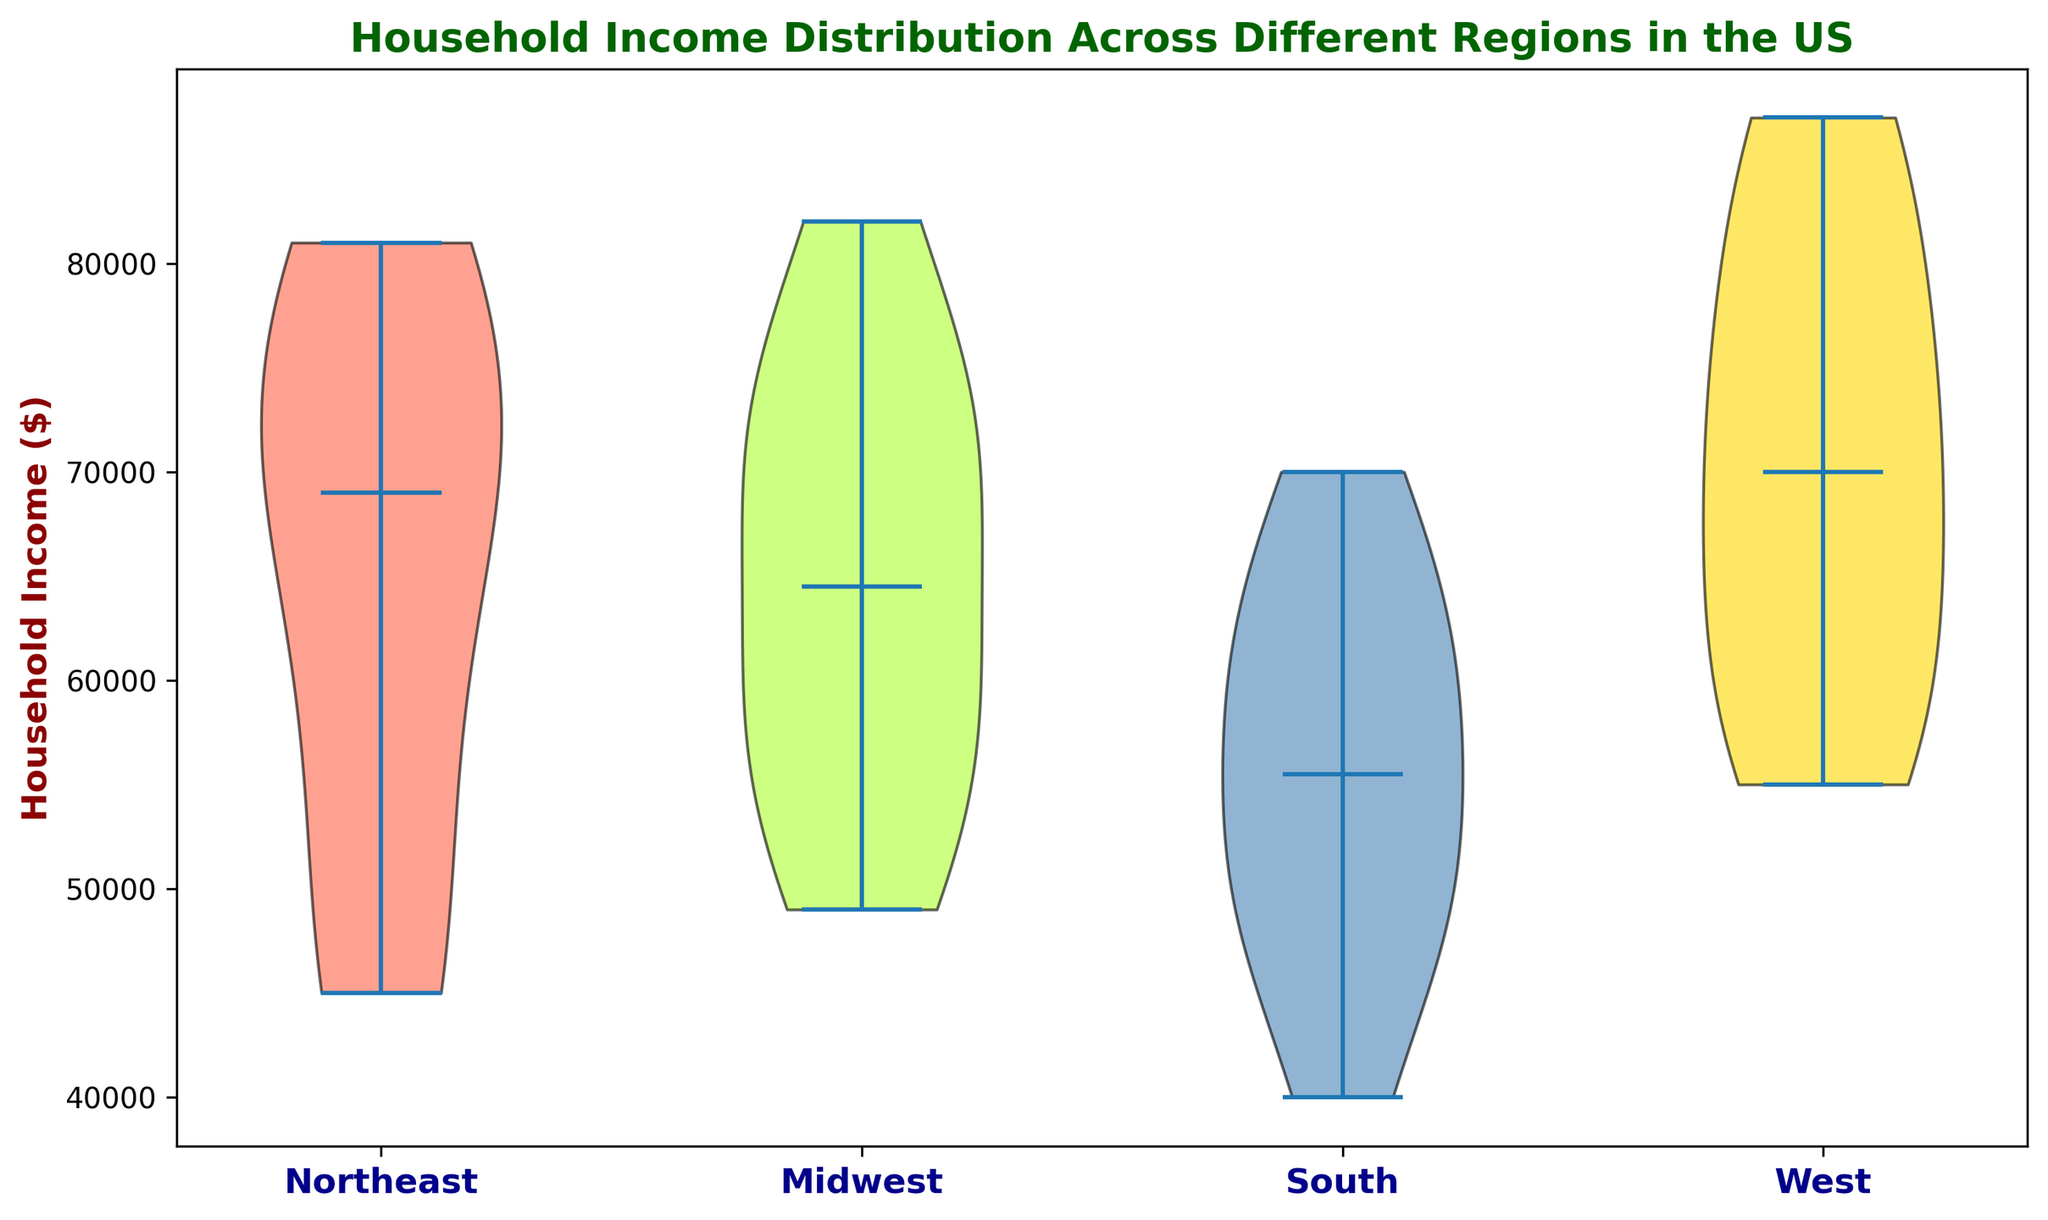What's the median household income in the Midwest region? Look at the violin plot for the Midwest region and identify the line that indicates the median value (shown as a black line). The median line appears around 68,000.
Answer: 68,000 Which region has the highest median household income? Compare the median lines (black lines) of all the regions on the violin plot. The West region shows the highest median line, indicating the highest median household income.
Answer: West What is the range of household incomes in the South region? Identify the lowest and highest points of the violin plot for the South region. The range is from around 40,000 to 70,000.
Answer: 40,000 to 70,000 Which region shows the most spread out household incomes? Examine the widths of the violin plots for each region. The West region has the widest violin plot, indicating the most spread out household incomes.
Answer: West How do the distributions of income between the Northeast and the Midwest compare? Compare the shapes of the violin plots for both the Northeast and Midwest regions. Both regions have a similar shape, but the Midwest has a slightly higher median and a wider spread.
Answer: Northeast is more centralized, Midwest is more spread out Which region has the smallest range of household incomes? Identify the region with the narrowest violin plot. The Northeast has the smallest range, with household incomes ranging from around 45,000 to 81,000.
Answer: Northeast If a household earns 60,000 dollars, in which regional distribution would it most likely fall within the central 50% range? The central regions of the violin plot represent the interquartile range (IQR). For a household earning 60,000 dollars, the South and Midwest regions' central parts overlap 60,000.
Answer: South or Midwest What's the median household income in the West region? Look at the violin plot for the West region and identify the line that indicates the median value (shown as a black line). The median line appears around 71,000.
Answer: 71,000 Which color represents the South region, and what is its significance? Identify the color used for the South region's violin plot and understand it as a means to differentiate regions. The South region is depicted in green. This visual distinction helps in easily identifying and comparing regions.
Answer: Green 